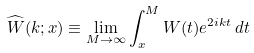Convert formula to latex. <formula><loc_0><loc_0><loc_500><loc_500>\widehat { W } ( k ; x ) \equiv \lim _ { M \to \infty } \int _ { x } ^ { M } W ( t ) e ^ { 2 i k t } \, d t</formula> 